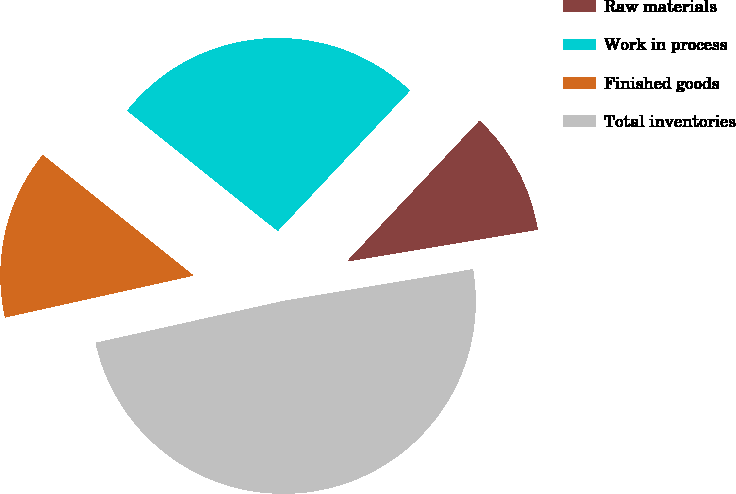Convert chart. <chart><loc_0><loc_0><loc_500><loc_500><pie_chart><fcel>Raw materials<fcel>Work in process<fcel>Finished goods<fcel>Total inventories<nl><fcel>10.34%<fcel>26.29%<fcel>14.22%<fcel>49.16%<nl></chart> 